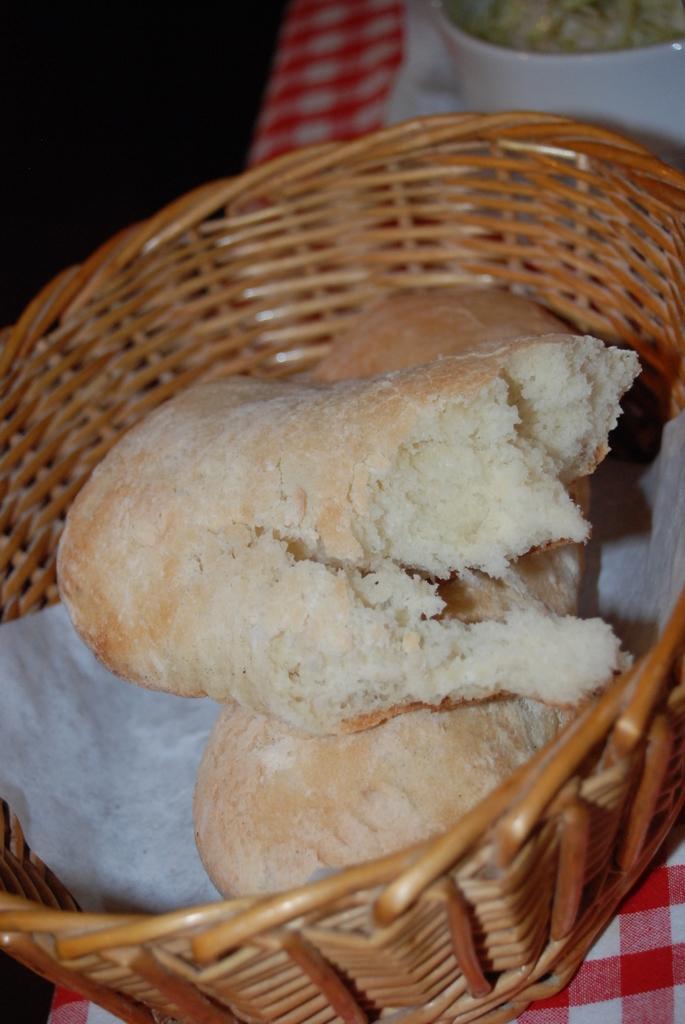Could you give a brief overview of what you see in this image? In this image there is a basket in which there are two pieces of bread. The basket is kept on the cloth. 